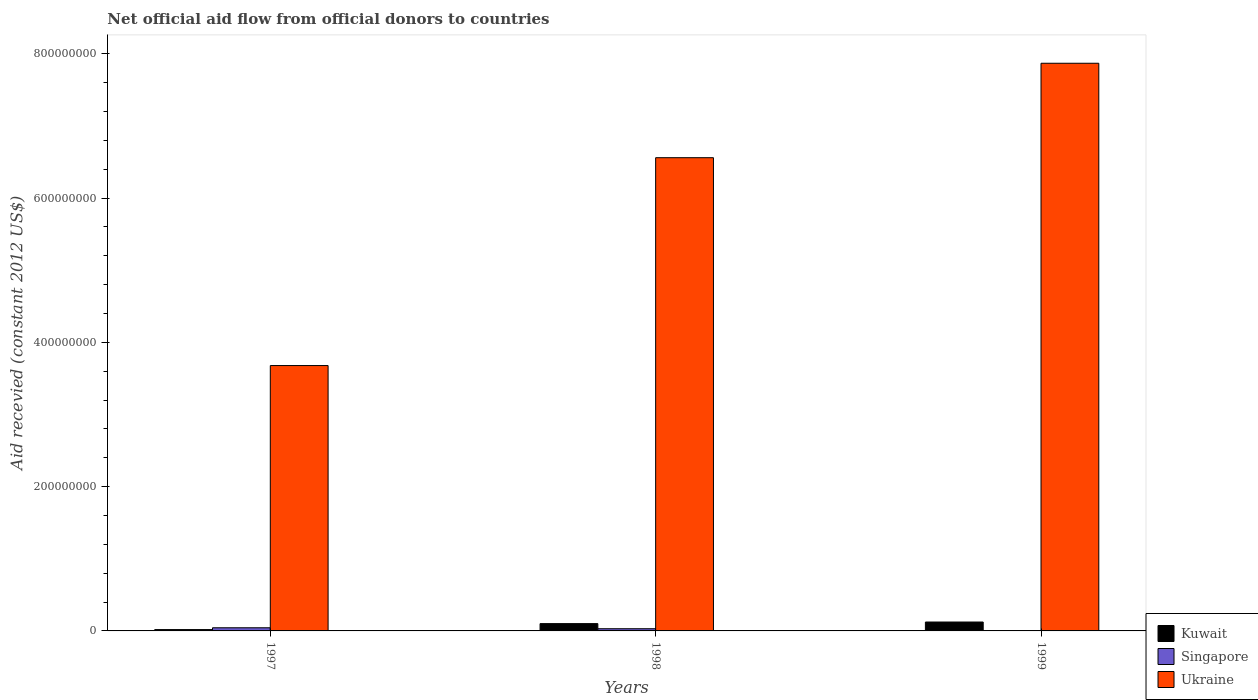How many groups of bars are there?
Provide a succinct answer. 3. How many bars are there on the 3rd tick from the left?
Your response must be concise. 2. What is the label of the 1st group of bars from the left?
Ensure brevity in your answer.  1997. In how many cases, is the number of bars for a given year not equal to the number of legend labels?
Ensure brevity in your answer.  1. What is the total aid received in Ukraine in 1997?
Your answer should be very brief. 3.68e+08. Across all years, what is the maximum total aid received in Kuwait?
Ensure brevity in your answer.  1.23e+07. What is the total total aid received in Ukraine in the graph?
Your answer should be compact. 1.81e+09. What is the difference between the total aid received in Ukraine in 1997 and that in 1998?
Your answer should be very brief. -2.88e+08. What is the difference between the total aid received in Kuwait in 1997 and the total aid received in Singapore in 1999?
Provide a short and direct response. 1.85e+06. What is the average total aid received in Singapore per year?
Ensure brevity in your answer.  2.47e+06. In the year 1998, what is the difference between the total aid received in Kuwait and total aid received in Singapore?
Offer a very short reply. 7.09e+06. What is the ratio of the total aid received in Kuwait in 1997 to that in 1999?
Keep it short and to the point. 0.15. Is the total aid received in Kuwait in 1997 less than that in 1998?
Your response must be concise. Yes. What is the difference between the highest and the second highest total aid received in Ukraine?
Your answer should be very brief. 1.31e+08. What is the difference between the highest and the lowest total aid received in Kuwait?
Give a very brief answer. 1.05e+07. In how many years, is the total aid received in Kuwait greater than the average total aid received in Kuwait taken over all years?
Provide a short and direct response. 2. Is the sum of the total aid received in Ukraine in 1998 and 1999 greater than the maximum total aid received in Kuwait across all years?
Ensure brevity in your answer.  Yes. How many bars are there?
Offer a terse response. 8. Are all the bars in the graph horizontal?
Offer a very short reply. No. Are the values on the major ticks of Y-axis written in scientific E-notation?
Offer a terse response. No. Does the graph contain grids?
Ensure brevity in your answer.  No. How many legend labels are there?
Provide a succinct answer. 3. What is the title of the graph?
Make the answer very short. Net official aid flow from official donors to countries. Does "Korea (Republic)" appear as one of the legend labels in the graph?
Provide a short and direct response. No. What is the label or title of the Y-axis?
Keep it short and to the point. Aid recevied (constant 2012 US$). What is the Aid recevied (constant 2012 US$) in Kuwait in 1997?
Ensure brevity in your answer.  1.85e+06. What is the Aid recevied (constant 2012 US$) of Singapore in 1997?
Ensure brevity in your answer.  4.37e+06. What is the Aid recevied (constant 2012 US$) in Ukraine in 1997?
Provide a succinct answer. 3.68e+08. What is the Aid recevied (constant 2012 US$) in Kuwait in 1998?
Give a very brief answer. 1.01e+07. What is the Aid recevied (constant 2012 US$) of Singapore in 1998?
Offer a terse response. 3.04e+06. What is the Aid recevied (constant 2012 US$) of Ukraine in 1998?
Ensure brevity in your answer.  6.56e+08. What is the Aid recevied (constant 2012 US$) in Kuwait in 1999?
Ensure brevity in your answer.  1.23e+07. What is the Aid recevied (constant 2012 US$) of Ukraine in 1999?
Your answer should be compact. 7.87e+08. Across all years, what is the maximum Aid recevied (constant 2012 US$) of Kuwait?
Give a very brief answer. 1.23e+07. Across all years, what is the maximum Aid recevied (constant 2012 US$) of Singapore?
Offer a very short reply. 4.37e+06. Across all years, what is the maximum Aid recevied (constant 2012 US$) in Ukraine?
Give a very brief answer. 7.87e+08. Across all years, what is the minimum Aid recevied (constant 2012 US$) in Kuwait?
Offer a terse response. 1.85e+06. Across all years, what is the minimum Aid recevied (constant 2012 US$) of Ukraine?
Your answer should be compact. 3.68e+08. What is the total Aid recevied (constant 2012 US$) in Kuwait in the graph?
Your answer should be compact. 2.43e+07. What is the total Aid recevied (constant 2012 US$) of Singapore in the graph?
Make the answer very short. 7.41e+06. What is the total Aid recevied (constant 2012 US$) of Ukraine in the graph?
Offer a very short reply. 1.81e+09. What is the difference between the Aid recevied (constant 2012 US$) in Kuwait in 1997 and that in 1998?
Ensure brevity in your answer.  -8.28e+06. What is the difference between the Aid recevied (constant 2012 US$) of Singapore in 1997 and that in 1998?
Your response must be concise. 1.33e+06. What is the difference between the Aid recevied (constant 2012 US$) in Ukraine in 1997 and that in 1998?
Your response must be concise. -2.88e+08. What is the difference between the Aid recevied (constant 2012 US$) of Kuwait in 1997 and that in 1999?
Your answer should be very brief. -1.05e+07. What is the difference between the Aid recevied (constant 2012 US$) in Ukraine in 1997 and that in 1999?
Your answer should be compact. -4.19e+08. What is the difference between the Aid recevied (constant 2012 US$) of Kuwait in 1998 and that in 1999?
Your answer should be compact. -2.20e+06. What is the difference between the Aid recevied (constant 2012 US$) of Ukraine in 1998 and that in 1999?
Provide a short and direct response. -1.31e+08. What is the difference between the Aid recevied (constant 2012 US$) of Kuwait in 1997 and the Aid recevied (constant 2012 US$) of Singapore in 1998?
Provide a short and direct response. -1.19e+06. What is the difference between the Aid recevied (constant 2012 US$) of Kuwait in 1997 and the Aid recevied (constant 2012 US$) of Ukraine in 1998?
Keep it short and to the point. -6.54e+08. What is the difference between the Aid recevied (constant 2012 US$) of Singapore in 1997 and the Aid recevied (constant 2012 US$) of Ukraine in 1998?
Ensure brevity in your answer.  -6.52e+08. What is the difference between the Aid recevied (constant 2012 US$) of Kuwait in 1997 and the Aid recevied (constant 2012 US$) of Ukraine in 1999?
Offer a very short reply. -7.85e+08. What is the difference between the Aid recevied (constant 2012 US$) in Singapore in 1997 and the Aid recevied (constant 2012 US$) in Ukraine in 1999?
Provide a short and direct response. -7.82e+08. What is the difference between the Aid recevied (constant 2012 US$) in Kuwait in 1998 and the Aid recevied (constant 2012 US$) in Ukraine in 1999?
Your response must be concise. -7.77e+08. What is the difference between the Aid recevied (constant 2012 US$) of Singapore in 1998 and the Aid recevied (constant 2012 US$) of Ukraine in 1999?
Ensure brevity in your answer.  -7.84e+08. What is the average Aid recevied (constant 2012 US$) in Kuwait per year?
Give a very brief answer. 8.10e+06. What is the average Aid recevied (constant 2012 US$) in Singapore per year?
Offer a very short reply. 2.47e+06. What is the average Aid recevied (constant 2012 US$) of Ukraine per year?
Ensure brevity in your answer.  6.04e+08. In the year 1997, what is the difference between the Aid recevied (constant 2012 US$) of Kuwait and Aid recevied (constant 2012 US$) of Singapore?
Provide a short and direct response. -2.52e+06. In the year 1997, what is the difference between the Aid recevied (constant 2012 US$) in Kuwait and Aid recevied (constant 2012 US$) in Ukraine?
Your answer should be very brief. -3.66e+08. In the year 1997, what is the difference between the Aid recevied (constant 2012 US$) of Singapore and Aid recevied (constant 2012 US$) of Ukraine?
Provide a short and direct response. -3.63e+08. In the year 1998, what is the difference between the Aid recevied (constant 2012 US$) in Kuwait and Aid recevied (constant 2012 US$) in Singapore?
Keep it short and to the point. 7.09e+06. In the year 1998, what is the difference between the Aid recevied (constant 2012 US$) of Kuwait and Aid recevied (constant 2012 US$) of Ukraine?
Your answer should be compact. -6.46e+08. In the year 1998, what is the difference between the Aid recevied (constant 2012 US$) in Singapore and Aid recevied (constant 2012 US$) in Ukraine?
Your response must be concise. -6.53e+08. In the year 1999, what is the difference between the Aid recevied (constant 2012 US$) in Kuwait and Aid recevied (constant 2012 US$) in Ukraine?
Give a very brief answer. -7.75e+08. What is the ratio of the Aid recevied (constant 2012 US$) of Kuwait in 1997 to that in 1998?
Make the answer very short. 0.18. What is the ratio of the Aid recevied (constant 2012 US$) of Singapore in 1997 to that in 1998?
Your answer should be very brief. 1.44. What is the ratio of the Aid recevied (constant 2012 US$) of Ukraine in 1997 to that in 1998?
Offer a terse response. 0.56. What is the ratio of the Aid recevied (constant 2012 US$) of Ukraine in 1997 to that in 1999?
Offer a very short reply. 0.47. What is the ratio of the Aid recevied (constant 2012 US$) in Kuwait in 1998 to that in 1999?
Offer a very short reply. 0.82. What is the ratio of the Aid recevied (constant 2012 US$) in Ukraine in 1998 to that in 1999?
Your answer should be compact. 0.83. What is the difference between the highest and the second highest Aid recevied (constant 2012 US$) in Kuwait?
Your response must be concise. 2.20e+06. What is the difference between the highest and the second highest Aid recevied (constant 2012 US$) of Ukraine?
Provide a succinct answer. 1.31e+08. What is the difference between the highest and the lowest Aid recevied (constant 2012 US$) of Kuwait?
Your answer should be compact. 1.05e+07. What is the difference between the highest and the lowest Aid recevied (constant 2012 US$) in Singapore?
Your response must be concise. 4.37e+06. What is the difference between the highest and the lowest Aid recevied (constant 2012 US$) in Ukraine?
Your answer should be compact. 4.19e+08. 